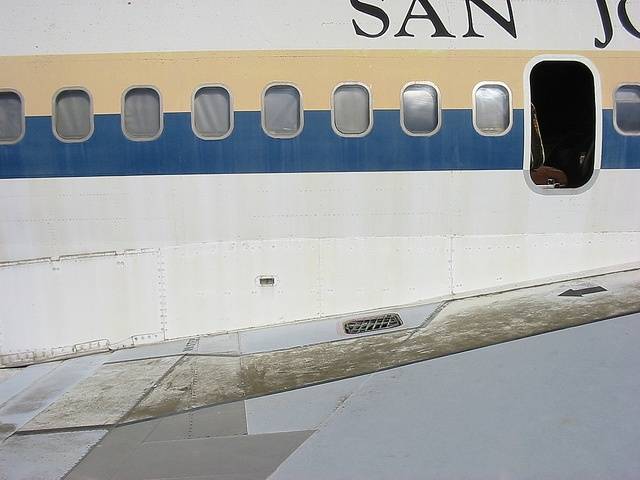Describe the objects in this image and their specific colors. I can see a airplane in lightgray, darkgray, tan, and blue tones in this image. 